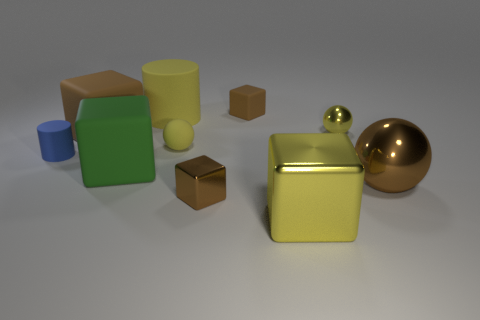What number of big yellow matte things have the same shape as the green rubber object?
Make the answer very short. 0. What is the big cube that is on the right side of the big brown rubber block and on the left side of the rubber ball made of?
Provide a succinct answer. Rubber. Do the large cylinder and the large sphere have the same material?
Keep it short and to the point. No. What number of small yellow objects are there?
Give a very brief answer. 2. What color is the thing that is on the right side of the small ball that is to the right of the small block that is behind the big brown matte thing?
Your answer should be compact. Brown. Is the tiny matte sphere the same color as the tiny rubber cylinder?
Offer a very short reply. No. What number of yellow objects are both behind the small rubber cylinder and in front of the tiny metallic block?
Give a very brief answer. 0. What number of metallic things are either big yellow blocks or big brown things?
Keep it short and to the point. 2. What is the material of the large yellow object behind the yellow metallic object behind the tiny cylinder?
Your response must be concise. Rubber. The matte object that is the same color as the large rubber cylinder is what shape?
Keep it short and to the point. Sphere. 